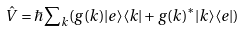Convert formula to latex. <formula><loc_0><loc_0><loc_500><loc_500>\hat { V } = \hbar { \sum } _ { k } ( g ( k ) | e \rangle \langle k | + g ( k ) ^ { * } | k \rangle \langle e | )</formula> 